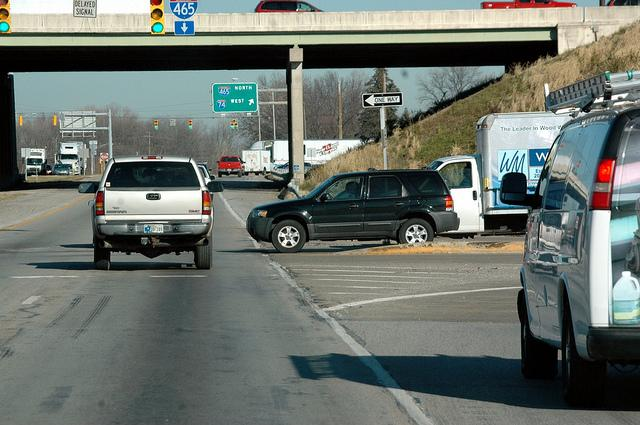How many traffic lights are hanging in the highway ahead facing toward the silver pickup truck? two 